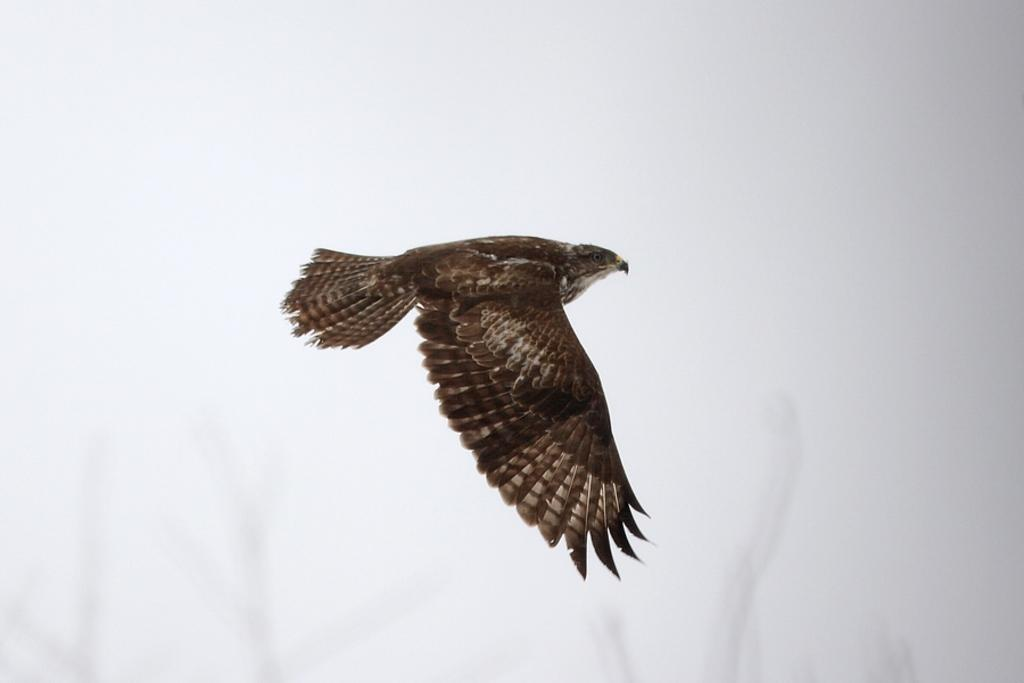What type of animal can be seen in the image? There is a bird in the image. What is the bird doing in the image? The bird is flying in the air. What color is the background of the image? The background of the image is white in color. Can you hear the bird laugh in the image? There is no sound in the image, so it is not possible to hear the bird laugh. 